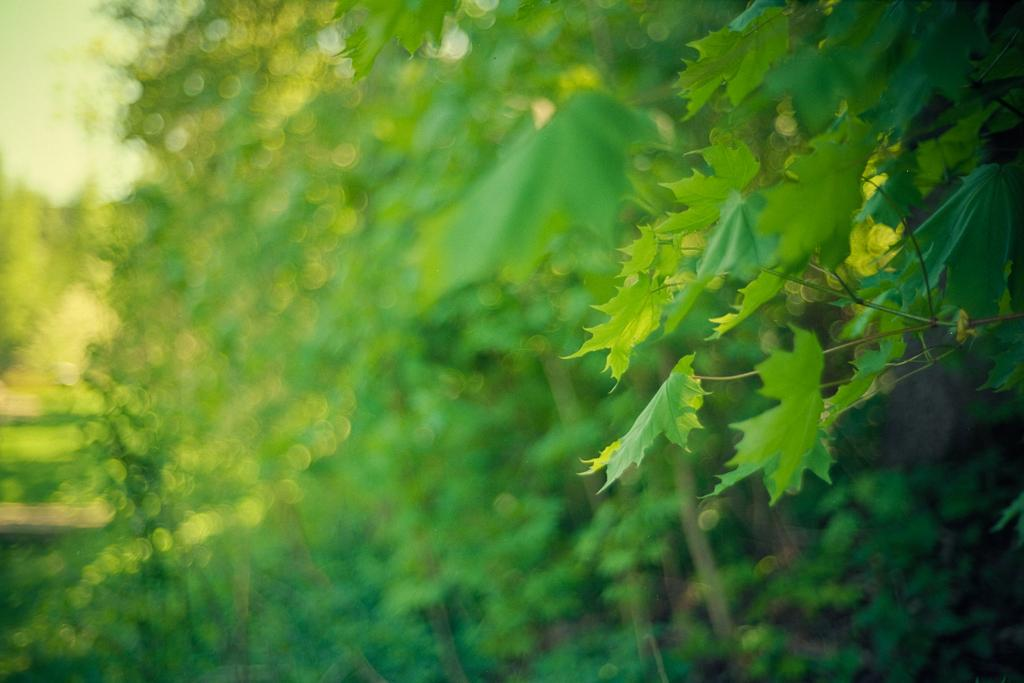What type of vegetation is present in the image? There are green leaves and green stems in the image. What colors are present in the background of the image? The background of the image is blue and green. Where is the key located in the image? There is no key present in the image. What type of flame can be seen in the image? There is no flame present in the image. 